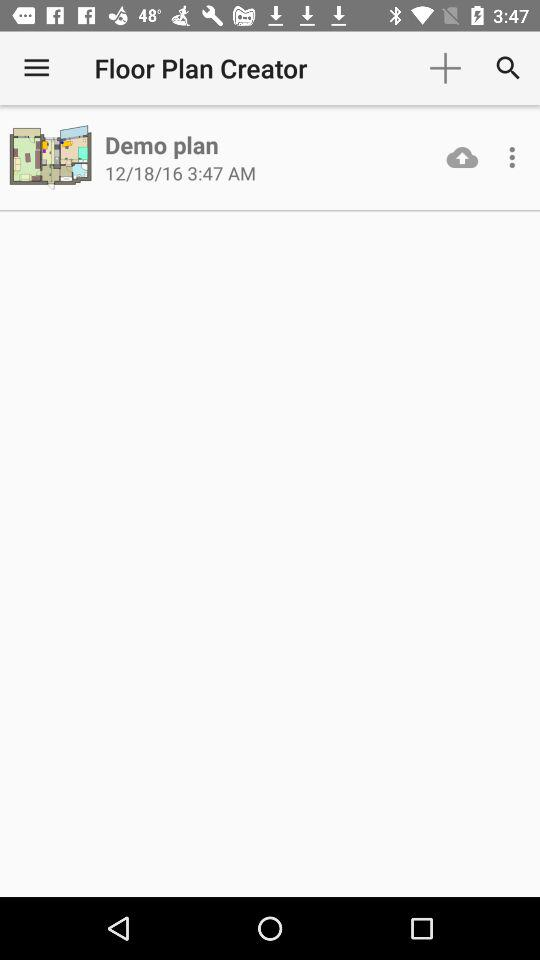What is the application name? The application name is "Floor Plan Creator". 